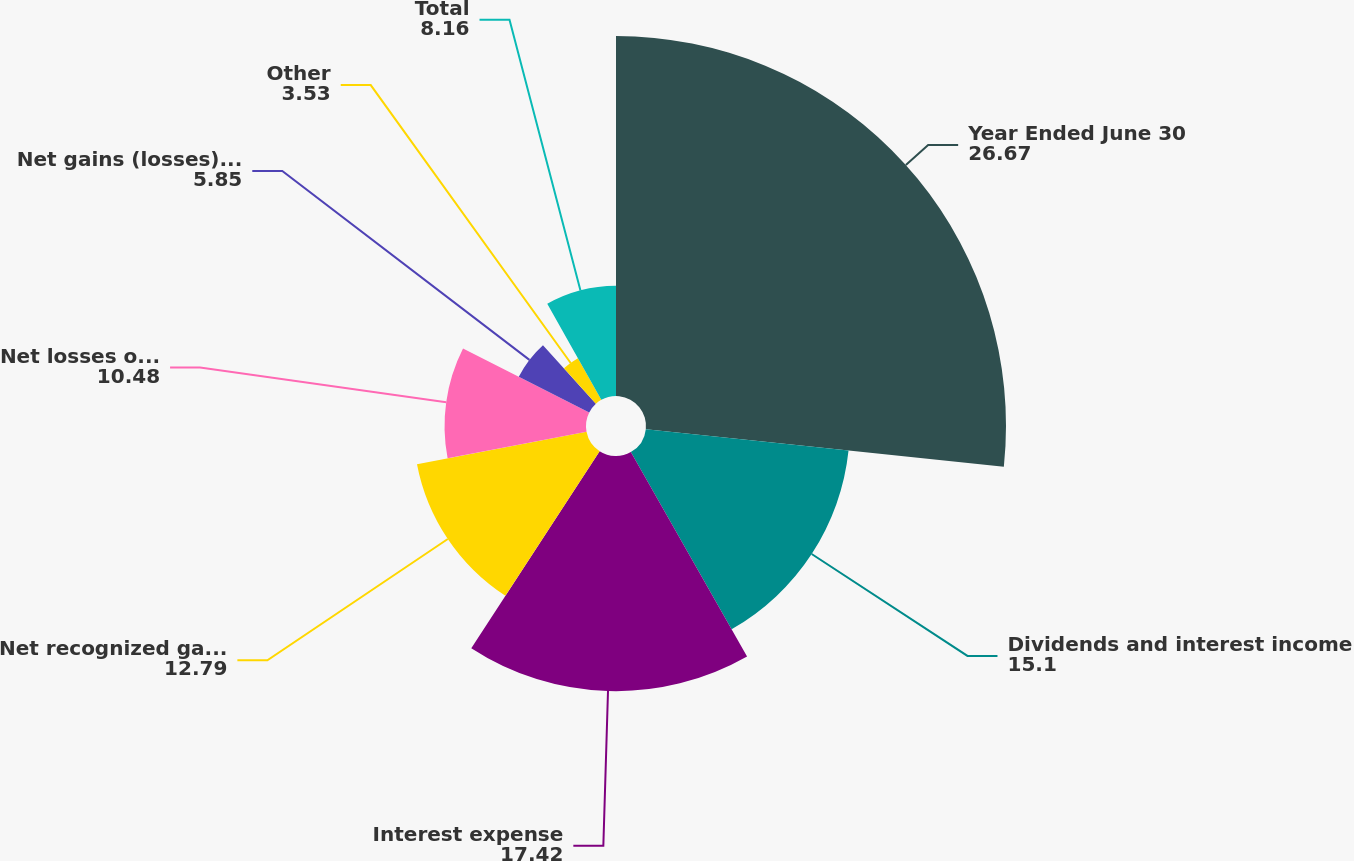Convert chart to OTSL. <chart><loc_0><loc_0><loc_500><loc_500><pie_chart><fcel>Year Ended June 30<fcel>Dividends and interest income<fcel>Interest expense<fcel>Net recognized gains on<fcel>Net losses on derivatives<fcel>Net gains (losses) on foreign<fcel>Other<fcel>Total<nl><fcel>26.67%<fcel>15.1%<fcel>17.42%<fcel>12.79%<fcel>10.48%<fcel>5.85%<fcel>3.53%<fcel>8.16%<nl></chart> 